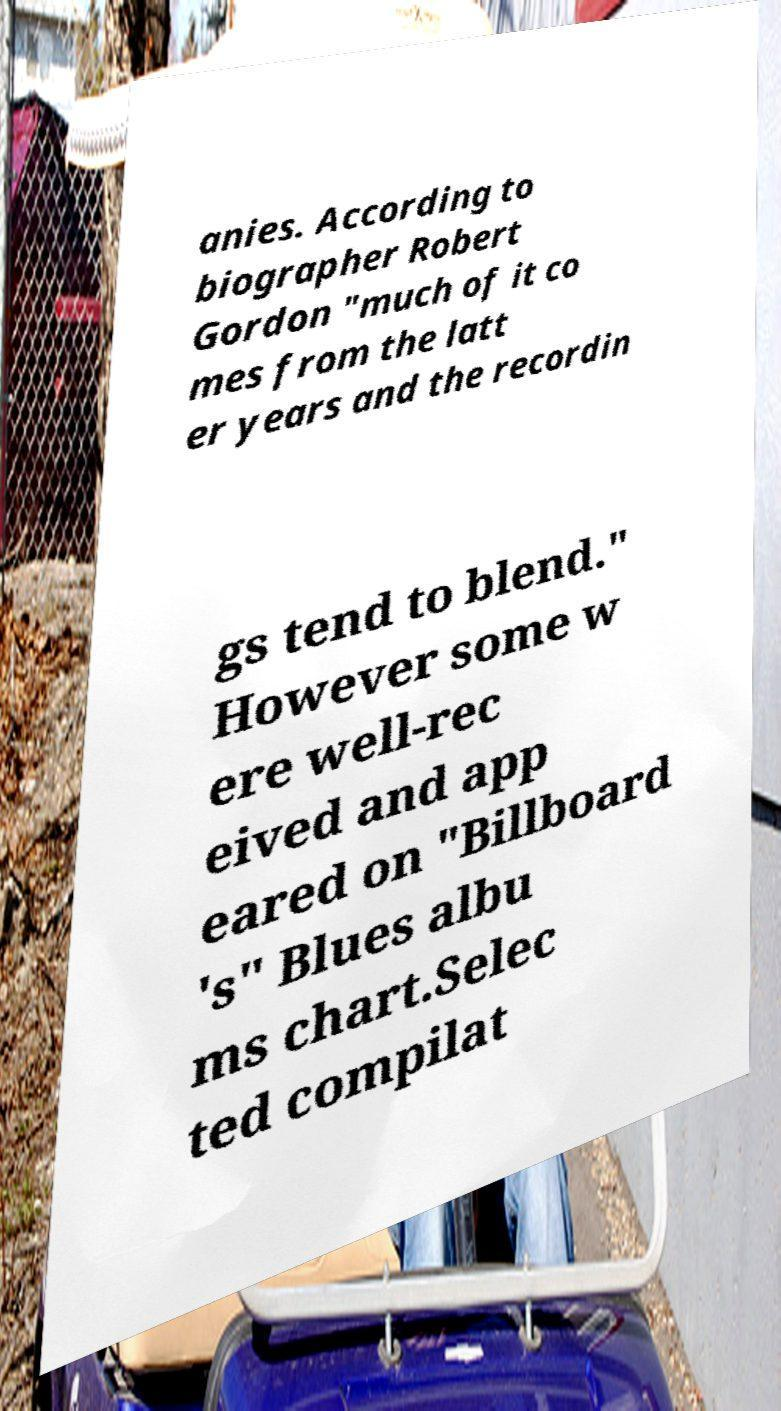There's text embedded in this image that I need extracted. Can you transcribe it verbatim? anies. According to biographer Robert Gordon "much of it co mes from the latt er years and the recordin gs tend to blend." However some w ere well-rec eived and app eared on "Billboard 's" Blues albu ms chart.Selec ted compilat 